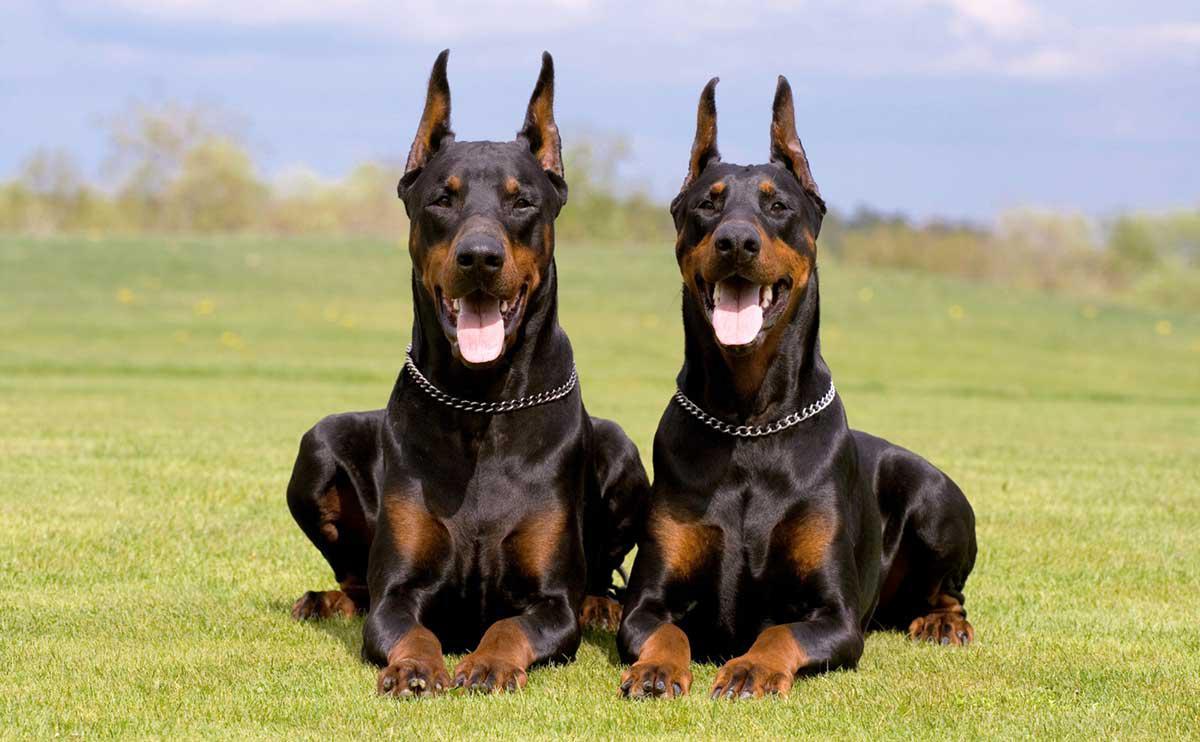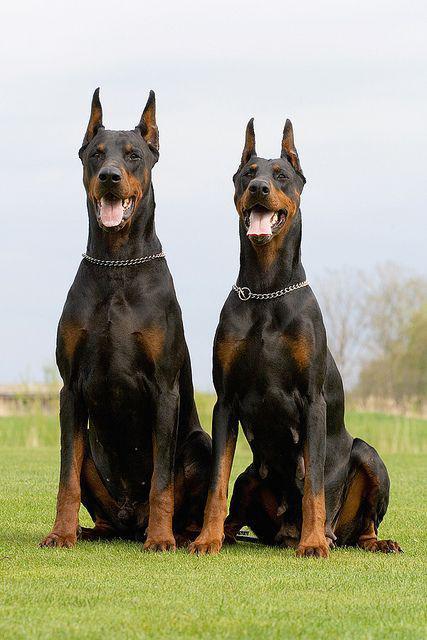The first image is the image on the left, the second image is the image on the right. Examine the images to the left and right. Is the description "One image is a full-grown dog and one is not." accurate? Answer yes or no. No. The first image is the image on the left, the second image is the image on the right. Analyze the images presented: Is the assertion "One image shows a single floppy-eared puppy in a standing pose, and the other image shows an adult dog in profile with its body turned leftward." valid? Answer yes or no. No. 